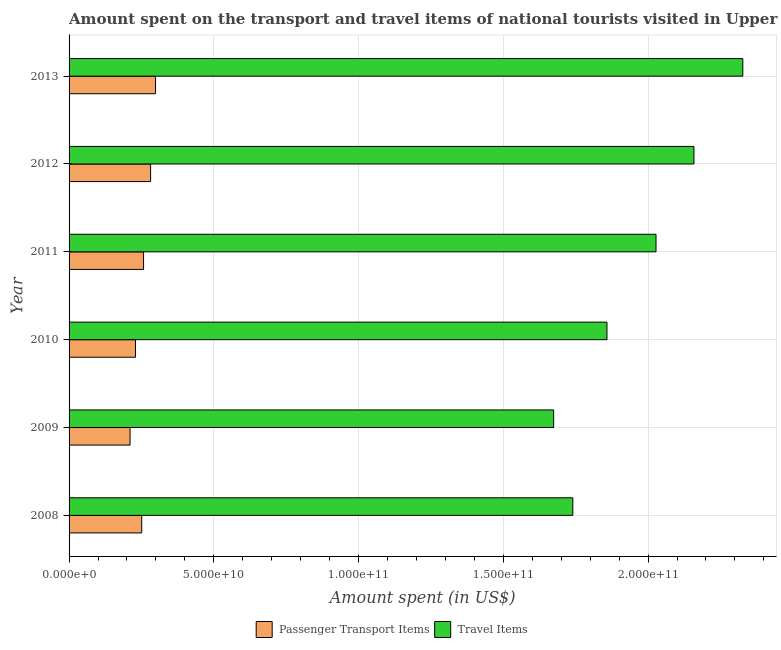How many different coloured bars are there?
Your response must be concise. 2. How many bars are there on the 3rd tick from the bottom?
Offer a terse response. 2. In how many cases, is the number of bars for a given year not equal to the number of legend labels?
Offer a very short reply. 0. What is the amount spent on passenger transport items in 2010?
Your response must be concise. 2.29e+1. Across all years, what is the maximum amount spent on passenger transport items?
Your answer should be very brief. 2.99e+1. Across all years, what is the minimum amount spent on passenger transport items?
Your answer should be compact. 2.11e+1. In which year was the amount spent on passenger transport items minimum?
Keep it short and to the point. 2009. What is the total amount spent in travel items in the graph?
Keep it short and to the point. 1.18e+12. What is the difference between the amount spent in travel items in 2012 and that in 2013?
Provide a succinct answer. -1.69e+1. What is the difference between the amount spent in travel items in 2010 and the amount spent on passenger transport items in 2013?
Your response must be concise. 1.56e+11. What is the average amount spent on passenger transport items per year?
Keep it short and to the point. 2.55e+1. In the year 2009, what is the difference between the amount spent in travel items and amount spent on passenger transport items?
Offer a very short reply. 1.46e+11. What is the ratio of the amount spent in travel items in 2009 to that in 2013?
Ensure brevity in your answer.  0.72. Is the difference between the amount spent on passenger transport items in 2009 and 2010 greater than the difference between the amount spent in travel items in 2009 and 2010?
Keep it short and to the point. Yes. What is the difference between the highest and the second highest amount spent on passenger transport items?
Your response must be concise. 1.70e+09. What is the difference between the highest and the lowest amount spent on passenger transport items?
Keep it short and to the point. 8.81e+09. Is the sum of the amount spent on passenger transport items in 2008 and 2009 greater than the maximum amount spent in travel items across all years?
Make the answer very short. No. What does the 2nd bar from the top in 2008 represents?
Give a very brief answer. Passenger Transport Items. What does the 1st bar from the bottom in 2013 represents?
Give a very brief answer. Passenger Transport Items. How many bars are there?
Provide a succinct answer. 12. Are all the bars in the graph horizontal?
Your answer should be compact. Yes. How many years are there in the graph?
Your answer should be very brief. 6. What is the difference between two consecutive major ticks on the X-axis?
Your answer should be very brief. 5.00e+1. Are the values on the major ticks of X-axis written in scientific E-notation?
Keep it short and to the point. Yes. Does the graph contain any zero values?
Your answer should be very brief. No. Where does the legend appear in the graph?
Keep it short and to the point. Bottom center. What is the title of the graph?
Ensure brevity in your answer.  Amount spent on the transport and travel items of national tourists visited in Upper middle income. What is the label or title of the X-axis?
Give a very brief answer. Amount spent (in US$). What is the Amount spent (in US$) of Passenger Transport Items in 2008?
Give a very brief answer. 2.51e+1. What is the Amount spent (in US$) of Travel Items in 2008?
Make the answer very short. 1.74e+11. What is the Amount spent (in US$) of Passenger Transport Items in 2009?
Give a very brief answer. 2.11e+1. What is the Amount spent (in US$) in Travel Items in 2009?
Provide a succinct answer. 1.67e+11. What is the Amount spent (in US$) in Passenger Transport Items in 2010?
Keep it short and to the point. 2.29e+1. What is the Amount spent (in US$) in Travel Items in 2010?
Your response must be concise. 1.86e+11. What is the Amount spent (in US$) of Passenger Transport Items in 2011?
Give a very brief answer. 2.57e+1. What is the Amount spent (in US$) in Travel Items in 2011?
Provide a succinct answer. 2.03e+11. What is the Amount spent (in US$) of Passenger Transport Items in 2012?
Make the answer very short. 2.82e+1. What is the Amount spent (in US$) in Travel Items in 2012?
Keep it short and to the point. 2.16e+11. What is the Amount spent (in US$) of Passenger Transport Items in 2013?
Ensure brevity in your answer.  2.99e+1. What is the Amount spent (in US$) of Travel Items in 2013?
Your answer should be very brief. 2.33e+11. Across all years, what is the maximum Amount spent (in US$) in Passenger Transport Items?
Ensure brevity in your answer.  2.99e+1. Across all years, what is the maximum Amount spent (in US$) in Travel Items?
Provide a succinct answer. 2.33e+11. Across all years, what is the minimum Amount spent (in US$) in Passenger Transport Items?
Give a very brief answer. 2.11e+1. Across all years, what is the minimum Amount spent (in US$) of Travel Items?
Give a very brief answer. 1.67e+11. What is the total Amount spent (in US$) of Passenger Transport Items in the graph?
Ensure brevity in your answer.  1.53e+11. What is the total Amount spent (in US$) in Travel Items in the graph?
Ensure brevity in your answer.  1.18e+12. What is the difference between the Amount spent (in US$) in Passenger Transport Items in 2008 and that in 2009?
Offer a very short reply. 4.03e+09. What is the difference between the Amount spent (in US$) in Travel Items in 2008 and that in 2009?
Offer a very short reply. 6.63e+09. What is the difference between the Amount spent (in US$) in Passenger Transport Items in 2008 and that in 2010?
Offer a very short reply. 2.15e+09. What is the difference between the Amount spent (in US$) of Travel Items in 2008 and that in 2010?
Your response must be concise. -1.18e+1. What is the difference between the Amount spent (in US$) in Passenger Transport Items in 2008 and that in 2011?
Offer a terse response. -6.41e+08. What is the difference between the Amount spent (in US$) in Travel Items in 2008 and that in 2011?
Keep it short and to the point. -2.87e+1. What is the difference between the Amount spent (in US$) of Passenger Transport Items in 2008 and that in 2012?
Provide a short and direct response. -3.07e+09. What is the difference between the Amount spent (in US$) in Travel Items in 2008 and that in 2012?
Your answer should be very brief. -4.18e+1. What is the difference between the Amount spent (in US$) of Passenger Transport Items in 2008 and that in 2013?
Your answer should be very brief. -4.78e+09. What is the difference between the Amount spent (in US$) of Travel Items in 2008 and that in 2013?
Your answer should be very brief. -5.87e+1. What is the difference between the Amount spent (in US$) of Passenger Transport Items in 2009 and that in 2010?
Offer a terse response. -1.88e+09. What is the difference between the Amount spent (in US$) in Travel Items in 2009 and that in 2010?
Make the answer very short. -1.84e+1. What is the difference between the Amount spent (in US$) of Passenger Transport Items in 2009 and that in 2011?
Provide a short and direct response. -4.67e+09. What is the difference between the Amount spent (in US$) in Travel Items in 2009 and that in 2011?
Your answer should be very brief. -3.54e+1. What is the difference between the Amount spent (in US$) of Passenger Transport Items in 2009 and that in 2012?
Provide a short and direct response. -7.10e+09. What is the difference between the Amount spent (in US$) in Travel Items in 2009 and that in 2012?
Provide a succinct answer. -4.85e+1. What is the difference between the Amount spent (in US$) in Passenger Transport Items in 2009 and that in 2013?
Give a very brief answer. -8.81e+09. What is the difference between the Amount spent (in US$) of Travel Items in 2009 and that in 2013?
Offer a very short reply. -6.53e+1. What is the difference between the Amount spent (in US$) of Passenger Transport Items in 2010 and that in 2011?
Provide a short and direct response. -2.79e+09. What is the difference between the Amount spent (in US$) of Travel Items in 2010 and that in 2011?
Ensure brevity in your answer.  -1.69e+1. What is the difference between the Amount spent (in US$) in Passenger Transport Items in 2010 and that in 2012?
Offer a very short reply. -5.23e+09. What is the difference between the Amount spent (in US$) in Travel Items in 2010 and that in 2012?
Offer a terse response. -3.00e+1. What is the difference between the Amount spent (in US$) in Passenger Transport Items in 2010 and that in 2013?
Provide a succinct answer. -6.93e+09. What is the difference between the Amount spent (in US$) of Travel Items in 2010 and that in 2013?
Keep it short and to the point. -4.69e+1. What is the difference between the Amount spent (in US$) in Passenger Transport Items in 2011 and that in 2012?
Offer a terse response. -2.43e+09. What is the difference between the Amount spent (in US$) of Travel Items in 2011 and that in 2012?
Keep it short and to the point. -1.31e+1. What is the difference between the Amount spent (in US$) of Passenger Transport Items in 2011 and that in 2013?
Ensure brevity in your answer.  -4.13e+09. What is the difference between the Amount spent (in US$) of Travel Items in 2011 and that in 2013?
Give a very brief answer. -3.00e+1. What is the difference between the Amount spent (in US$) of Passenger Transport Items in 2012 and that in 2013?
Make the answer very short. -1.70e+09. What is the difference between the Amount spent (in US$) of Travel Items in 2012 and that in 2013?
Provide a succinct answer. -1.69e+1. What is the difference between the Amount spent (in US$) in Passenger Transport Items in 2008 and the Amount spent (in US$) in Travel Items in 2009?
Your response must be concise. -1.42e+11. What is the difference between the Amount spent (in US$) in Passenger Transport Items in 2008 and the Amount spent (in US$) in Travel Items in 2010?
Your answer should be very brief. -1.61e+11. What is the difference between the Amount spent (in US$) of Passenger Transport Items in 2008 and the Amount spent (in US$) of Travel Items in 2011?
Your answer should be very brief. -1.78e+11. What is the difference between the Amount spent (in US$) of Passenger Transport Items in 2008 and the Amount spent (in US$) of Travel Items in 2012?
Make the answer very short. -1.91e+11. What is the difference between the Amount spent (in US$) of Passenger Transport Items in 2008 and the Amount spent (in US$) of Travel Items in 2013?
Your answer should be compact. -2.08e+11. What is the difference between the Amount spent (in US$) in Passenger Transport Items in 2009 and the Amount spent (in US$) in Travel Items in 2010?
Provide a short and direct response. -1.65e+11. What is the difference between the Amount spent (in US$) of Passenger Transport Items in 2009 and the Amount spent (in US$) of Travel Items in 2011?
Make the answer very short. -1.82e+11. What is the difference between the Amount spent (in US$) in Passenger Transport Items in 2009 and the Amount spent (in US$) in Travel Items in 2012?
Provide a succinct answer. -1.95e+11. What is the difference between the Amount spent (in US$) in Passenger Transport Items in 2009 and the Amount spent (in US$) in Travel Items in 2013?
Your answer should be compact. -2.12e+11. What is the difference between the Amount spent (in US$) of Passenger Transport Items in 2010 and the Amount spent (in US$) of Travel Items in 2011?
Offer a very short reply. -1.80e+11. What is the difference between the Amount spent (in US$) in Passenger Transport Items in 2010 and the Amount spent (in US$) in Travel Items in 2012?
Give a very brief answer. -1.93e+11. What is the difference between the Amount spent (in US$) in Passenger Transport Items in 2010 and the Amount spent (in US$) in Travel Items in 2013?
Make the answer very short. -2.10e+11. What is the difference between the Amount spent (in US$) of Passenger Transport Items in 2011 and the Amount spent (in US$) of Travel Items in 2012?
Offer a very short reply. -1.90e+11. What is the difference between the Amount spent (in US$) of Passenger Transport Items in 2011 and the Amount spent (in US$) of Travel Items in 2013?
Your answer should be very brief. -2.07e+11. What is the difference between the Amount spent (in US$) in Passenger Transport Items in 2012 and the Amount spent (in US$) in Travel Items in 2013?
Your response must be concise. -2.05e+11. What is the average Amount spent (in US$) of Passenger Transport Items per year?
Provide a succinct answer. 2.55e+1. What is the average Amount spent (in US$) of Travel Items per year?
Give a very brief answer. 1.96e+11. In the year 2008, what is the difference between the Amount spent (in US$) in Passenger Transport Items and Amount spent (in US$) in Travel Items?
Offer a very short reply. -1.49e+11. In the year 2009, what is the difference between the Amount spent (in US$) of Passenger Transport Items and Amount spent (in US$) of Travel Items?
Keep it short and to the point. -1.46e+11. In the year 2010, what is the difference between the Amount spent (in US$) in Passenger Transport Items and Amount spent (in US$) in Travel Items?
Your answer should be compact. -1.63e+11. In the year 2011, what is the difference between the Amount spent (in US$) of Passenger Transport Items and Amount spent (in US$) of Travel Items?
Ensure brevity in your answer.  -1.77e+11. In the year 2012, what is the difference between the Amount spent (in US$) of Passenger Transport Items and Amount spent (in US$) of Travel Items?
Your answer should be very brief. -1.88e+11. In the year 2013, what is the difference between the Amount spent (in US$) of Passenger Transport Items and Amount spent (in US$) of Travel Items?
Your response must be concise. -2.03e+11. What is the ratio of the Amount spent (in US$) in Passenger Transport Items in 2008 to that in 2009?
Your answer should be compact. 1.19. What is the ratio of the Amount spent (in US$) in Travel Items in 2008 to that in 2009?
Make the answer very short. 1.04. What is the ratio of the Amount spent (in US$) of Passenger Transport Items in 2008 to that in 2010?
Your response must be concise. 1.09. What is the ratio of the Amount spent (in US$) in Travel Items in 2008 to that in 2010?
Your response must be concise. 0.94. What is the ratio of the Amount spent (in US$) in Passenger Transport Items in 2008 to that in 2011?
Provide a short and direct response. 0.98. What is the ratio of the Amount spent (in US$) of Travel Items in 2008 to that in 2011?
Your response must be concise. 0.86. What is the ratio of the Amount spent (in US$) of Passenger Transport Items in 2008 to that in 2012?
Ensure brevity in your answer.  0.89. What is the ratio of the Amount spent (in US$) of Travel Items in 2008 to that in 2012?
Provide a short and direct response. 0.81. What is the ratio of the Amount spent (in US$) of Passenger Transport Items in 2008 to that in 2013?
Give a very brief answer. 0.84. What is the ratio of the Amount spent (in US$) of Travel Items in 2008 to that in 2013?
Keep it short and to the point. 0.75. What is the ratio of the Amount spent (in US$) in Passenger Transport Items in 2009 to that in 2010?
Make the answer very short. 0.92. What is the ratio of the Amount spent (in US$) of Travel Items in 2009 to that in 2010?
Your answer should be compact. 0.9. What is the ratio of the Amount spent (in US$) in Passenger Transport Items in 2009 to that in 2011?
Your answer should be compact. 0.82. What is the ratio of the Amount spent (in US$) in Travel Items in 2009 to that in 2011?
Provide a succinct answer. 0.83. What is the ratio of the Amount spent (in US$) of Passenger Transport Items in 2009 to that in 2012?
Keep it short and to the point. 0.75. What is the ratio of the Amount spent (in US$) of Travel Items in 2009 to that in 2012?
Provide a succinct answer. 0.78. What is the ratio of the Amount spent (in US$) in Passenger Transport Items in 2009 to that in 2013?
Offer a terse response. 0.71. What is the ratio of the Amount spent (in US$) of Travel Items in 2009 to that in 2013?
Your response must be concise. 0.72. What is the ratio of the Amount spent (in US$) of Passenger Transport Items in 2010 to that in 2011?
Your response must be concise. 0.89. What is the ratio of the Amount spent (in US$) of Travel Items in 2010 to that in 2011?
Make the answer very short. 0.92. What is the ratio of the Amount spent (in US$) of Passenger Transport Items in 2010 to that in 2012?
Offer a terse response. 0.81. What is the ratio of the Amount spent (in US$) of Travel Items in 2010 to that in 2012?
Give a very brief answer. 0.86. What is the ratio of the Amount spent (in US$) in Passenger Transport Items in 2010 to that in 2013?
Provide a short and direct response. 0.77. What is the ratio of the Amount spent (in US$) in Travel Items in 2010 to that in 2013?
Offer a very short reply. 0.8. What is the ratio of the Amount spent (in US$) of Passenger Transport Items in 2011 to that in 2012?
Your response must be concise. 0.91. What is the ratio of the Amount spent (in US$) in Travel Items in 2011 to that in 2012?
Keep it short and to the point. 0.94. What is the ratio of the Amount spent (in US$) in Passenger Transport Items in 2011 to that in 2013?
Your answer should be very brief. 0.86. What is the ratio of the Amount spent (in US$) in Travel Items in 2011 to that in 2013?
Your response must be concise. 0.87. What is the ratio of the Amount spent (in US$) in Passenger Transport Items in 2012 to that in 2013?
Ensure brevity in your answer.  0.94. What is the ratio of the Amount spent (in US$) in Travel Items in 2012 to that in 2013?
Your answer should be very brief. 0.93. What is the difference between the highest and the second highest Amount spent (in US$) of Passenger Transport Items?
Offer a terse response. 1.70e+09. What is the difference between the highest and the second highest Amount spent (in US$) of Travel Items?
Offer a very short reply. 1.69e+1. What is the difference between the highest and the lowest Amount spent (in US$) in Passenger Transport Items?
Your answer should be compact. 8.81e+09. What is the difference between the highest and the lowest Amount spent (in US$) in Travel Items?
Provide a succinct answer. 6.53e+1. 